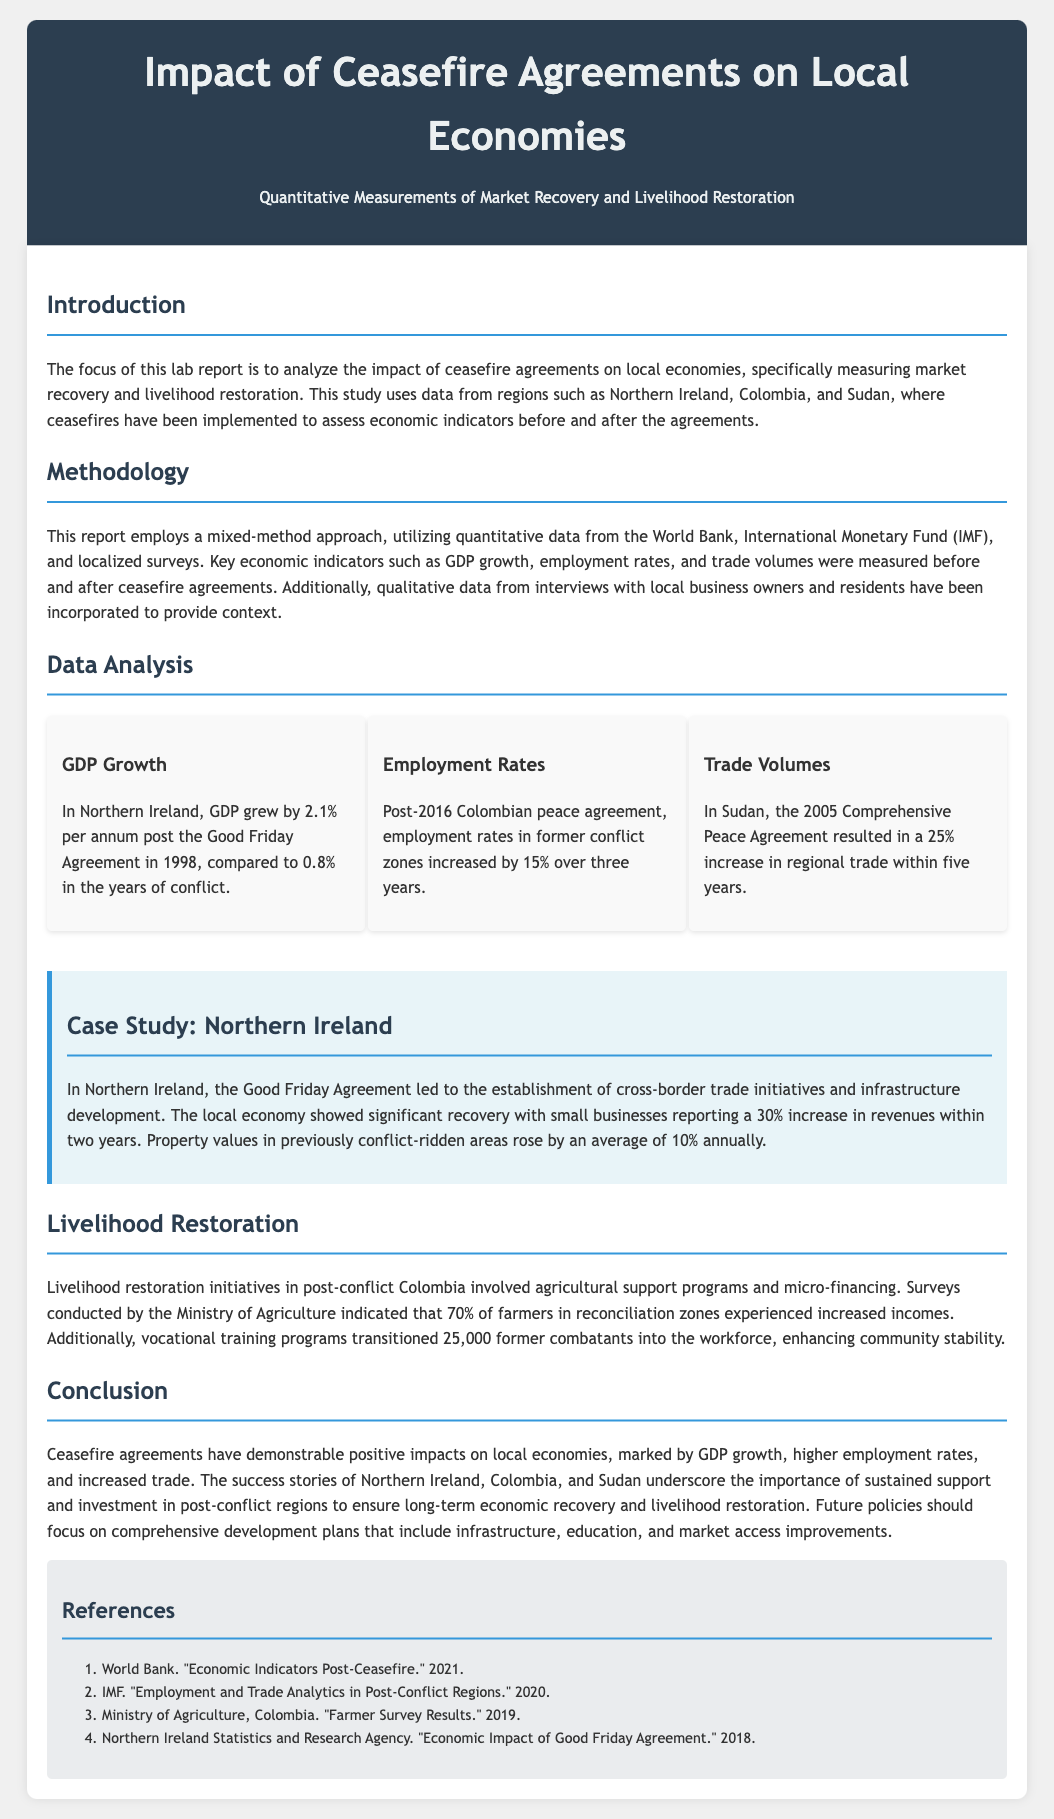what was the GDP growth in Northern Ireland post-agreement? The document states that in Northern Ireland, GDP grew by 2.1% per annum post the Good Friday Agreement in 1998.
Answer: 2.1% what was the employment rate increase in Colombia after the peace agreement? The report mentions that employment rates in former conflict zones in Colombia increased by 15% over three years post-2016 peace agreement.
Answer: 15% which agreement led to a 25% increase in regional trade in Sudan? The report refers to the 2005 Comprehensive Peace Agreement as the reason for the increase in regional trade within five years.
Answer: Comprehensive Peace Agreement what percentage of farmers in reconciliation zones experienced increased incomes in Colombia? According to the document, 70% of farmers in reconciliation zones indicated increased incomes.
Answer: 70% what was the average annual rise in property values in Northern Ireland? The case study indicates that property values in previously conflict-ridden areas rose by an average of 10% annually.
Answer: 10% how many former combatants transitioned into the workforce through vocational training programs? The document states that vocational training programs transitioned 25,000 former combatants into the workforce.
Answer: 25,000 what is the primary focus of this lab report? The introduction highlights that the focus is on analyzing the impact of ceasefire agreements on local economies.
Answer: local economies what type of data was primarily used in this study? The methodology section specifies that quantitative data from the World Bank and IMF was utilized.
Answer: quantitative data what is the conclusion regarding the impact of ceasefire agreements on local economies? The conclusion summarizes that ceasefire agreements have demonstrable positive impacts on local economies.
Answer: positive impacts 